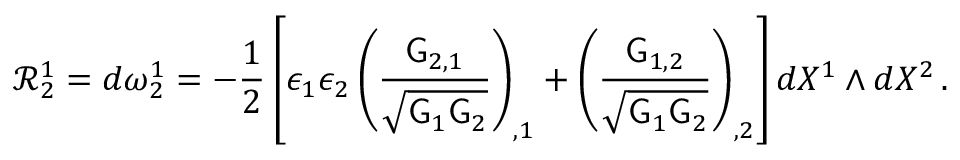<formula> <loc_0><loc_0><loc_500><loc_500>\mathcal { R } ^ { 1 } _ { 2 } = d \omega ^ { 1 } _ { 2 } = - \frac { 1 } { 2 } \left [ \epsilon _ { 1 } \epsilon _ { 2 } \left ( \frac { G _ { 2 , 1 } } { \sqrt { G _ { 1 } G _ { 2 } } } \right ) _ { , 1 } + \left ( \frac { G _ { 1 , 2 } } { \sqrt { G _ { 1 } G _ { 2 } } } \right ) _ { , 2 } \right ] d X ^ { 1 } \wedge d X ^ { 2 } \, .</formula> 